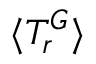<formula> <loc_0><loc_0><loc_500><loc_500>\langle T _ { r } ^ { G } \rangle</formula> 